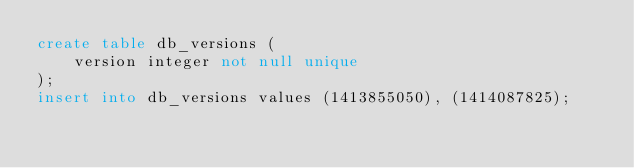Convert code to text. <code><loc_0><loc_0><loc_500><loc_500><_SQL_>create table db_versions (
    version integer not null unique
);
insert into db_versions values (1413855050), (1414087825);
</code> 